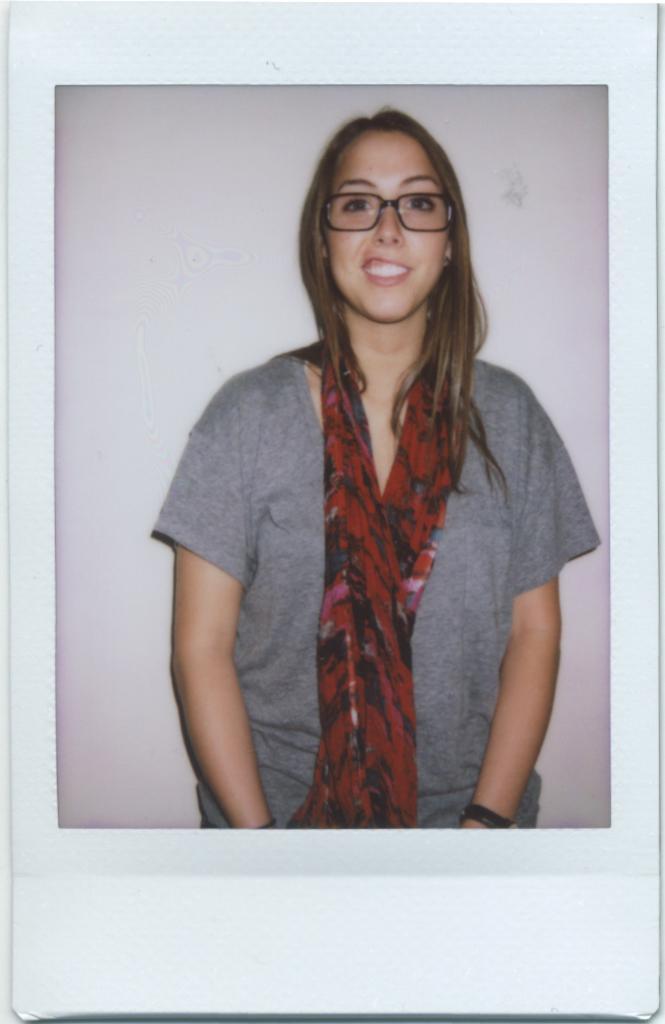Could you give a brief overview of what you see in this image? This image consists of a frame in which there is a woman wearing a gray T-shirt and a scarf in red color. In the background, there is a wall. 